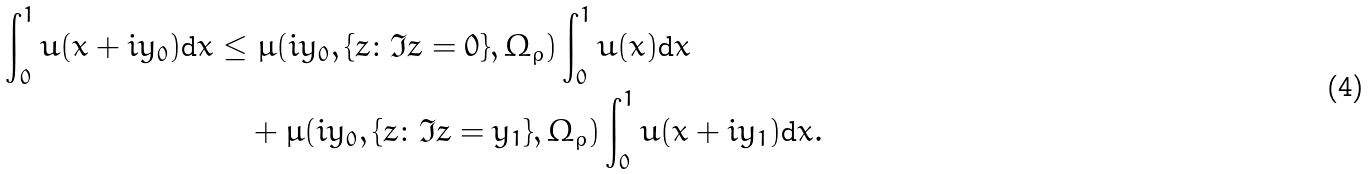<formula> <loc_0><loc_0><loc_500><loc_500>\int _ { 0 } ^ { 1 } u ( x + i y _ { 0 } ) \text {d} x \leq & \ \mu ( i y _ { 0 } , \{ z \colon \Im z = 0 \} , \Omega _ { \rho } ) \int _ { 0 } ^ { 1 } u ( x ) \text {d} x \\ & + \mu ( i y _ { 0 } , \{ z \colon \Im z = y _ { 1 } \} , \Omega _ { \rho } ) \int _ { 0 } ^ { 1 } u ( x + i y _ { 1 } ) \text {d} x . \\</formula> 